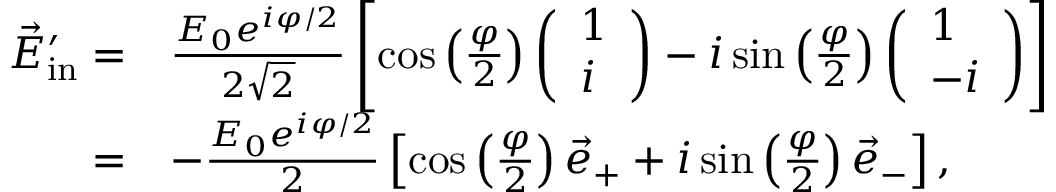Convert formula to latex. <formula><loc_0><loc_0><loc_500><loc_500>\begin{array} { r l } { \vec { E } _ { i n } ^ { \prime } = } & { \frac { E _ { 0 } e ^ { i \varphi / 2 } } { 2 \sqrt { 2 } } \left [ \cos \left ( \frac { \varphi } { 2 } \right ) \left ( \begin{array} { l } { 1 } \\ { i } \end{array} \right ) - i \sin \left ( \frac { \varphi } { 2 } \right ) \left ( \begin{array} { l } { 1 } \\ { - i } \end{array} \right ) \right ] } \\ { = } & { - \frac { E _ { 0 } e ^ { i \varphi / 2 } } { 2 } \left [ \cos \left ( \frac { \varphi } { 2 } \right ) \vec { e } _ { + } + i \sin \left ( \frac { \varphi } { 2 } \right ) \vec { e } _ { - } \right ] , } \end{array}</formula> 